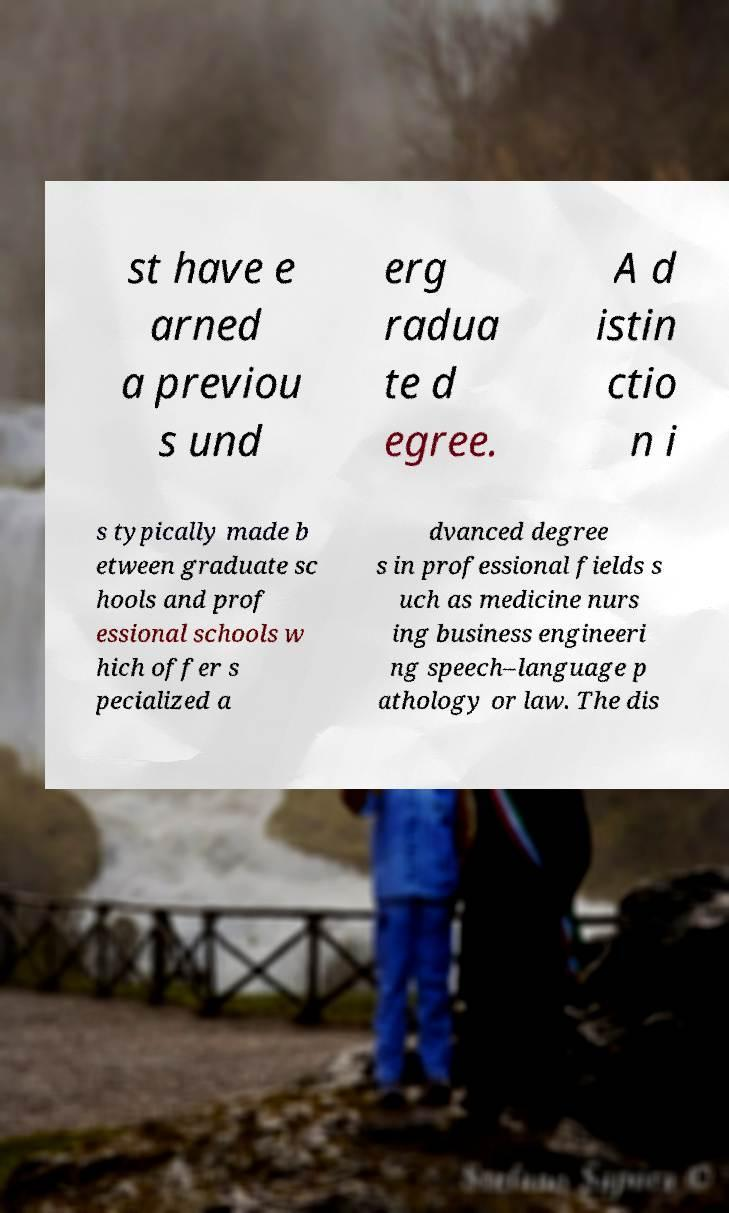What messages or text are displayed in this image? I need them in a readable, typed format. st have e arned a previou s und erg radua te d egree. A d istin ctio n i s typically made b etween graduate sc hools and prof essional schools w hich offer s pecialized a dvanced degree s in professional fields s uch as medicine nurs ing business engineeri ng speech–language p athology or law. The dis 